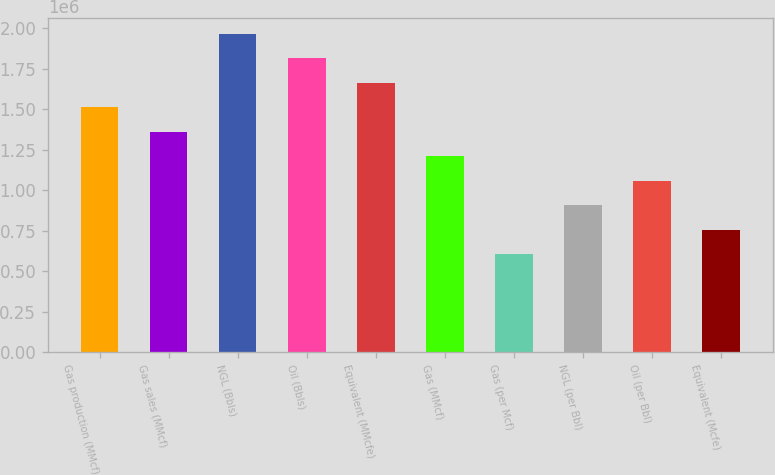<chart> <loc_0><loc_0><loc_500><loc_500><bar_chart><fcel>Gas production (MMcf)<fcel>Gas sales (MMcf)<fcel>NGL (Bbls)<fcel>Oil (Bbls)<fcel>Equivalent (MMcfe)<fcel>Gas (MMcf)<fcel>Gas (per Mcf)<fcel>NGL (per Bbl)<fcel>Oil (per Bbl)<fcel>Equivalent (Mcfe)<nl><fcel>1.51288e+06<fcel>1.36159e+06<fcel>1.96674e+06<fcel>1.81545e+06<fcel>1.66416e+06<fcel>1.2103e+06<fcel>605151<fcel>907726<fcel>1.05901e+06<fcel>756439<nl></chart> 